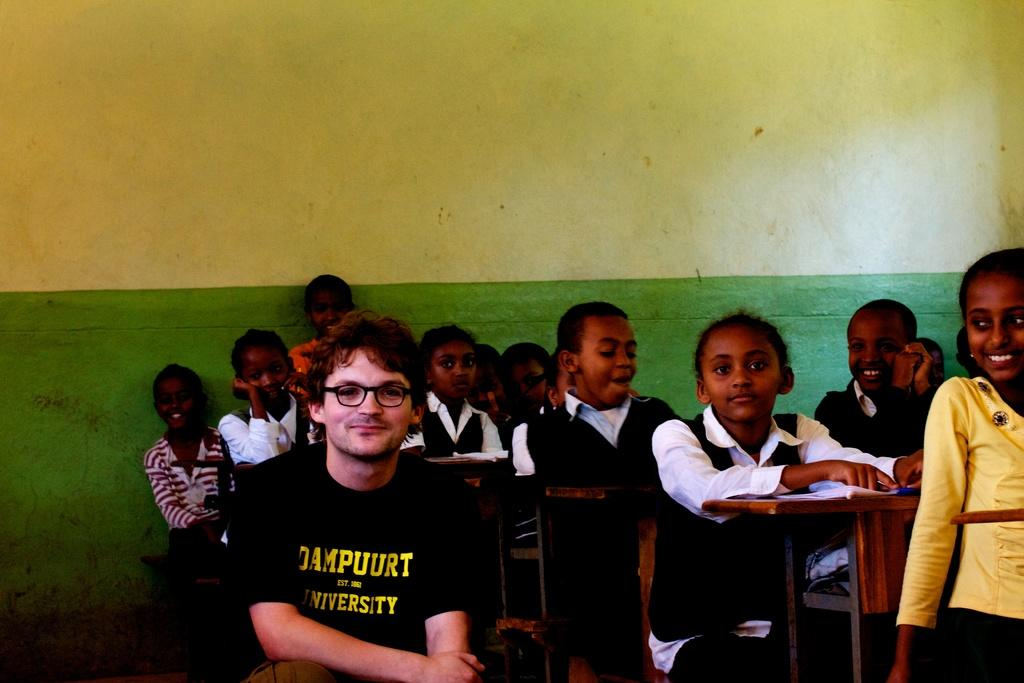What colors are present on the wall in the image? The wall in the image has green and yellow colors. What are the people in the image doing? The people in the image are sitting on benches. What type of camp can be seen in the image? There is no camp present in the image; it features a wall with green and yellow colors and people sitting on benches. How many people are joining the group in the image? There is no indication of people joining a group in the image; it only shows people sitting on benches. 